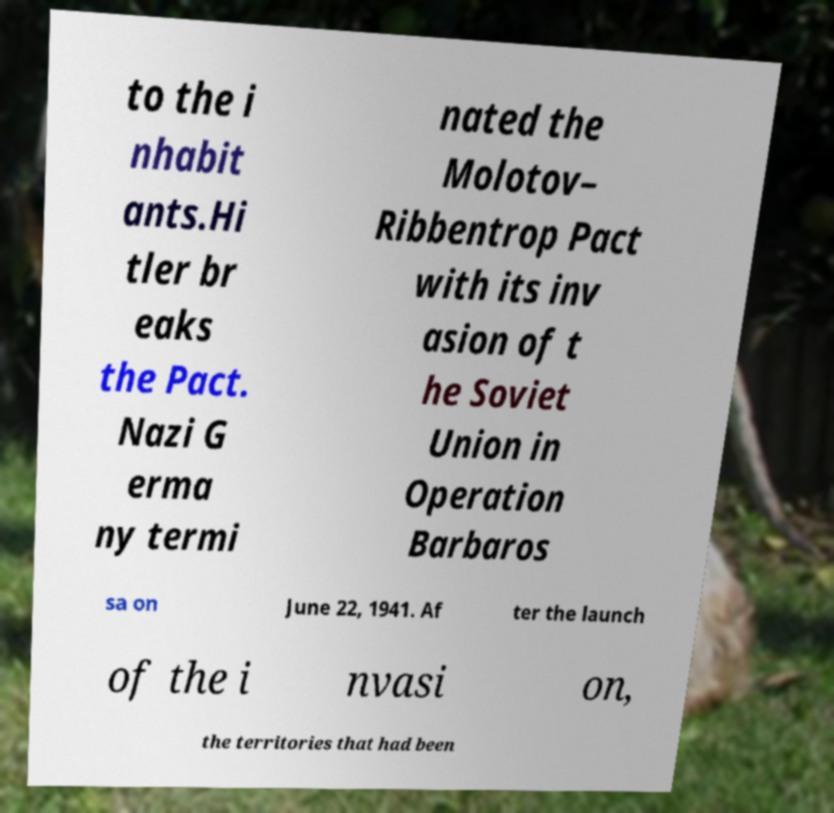For documentation purposes, I need the text within this image transcribed. Could you provide that? to the i nhabit ants.Hi tler br eaks the Pact. Nazi G erma ny termi nated the Molotov– Ribbentrop Pact with its inv asion of t he Soviet Union in Operation Barbaros sa on June 22, 1941. Af ter the launch of the i nvasi on, the territories that had been 